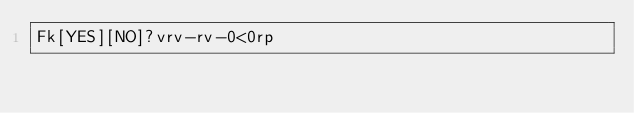Convert code to text. <code><loc_0><loc_0><loc_500><loc_500><_dc_>Fk[YES][NO]?vrv-rv-0<0rp</code> 